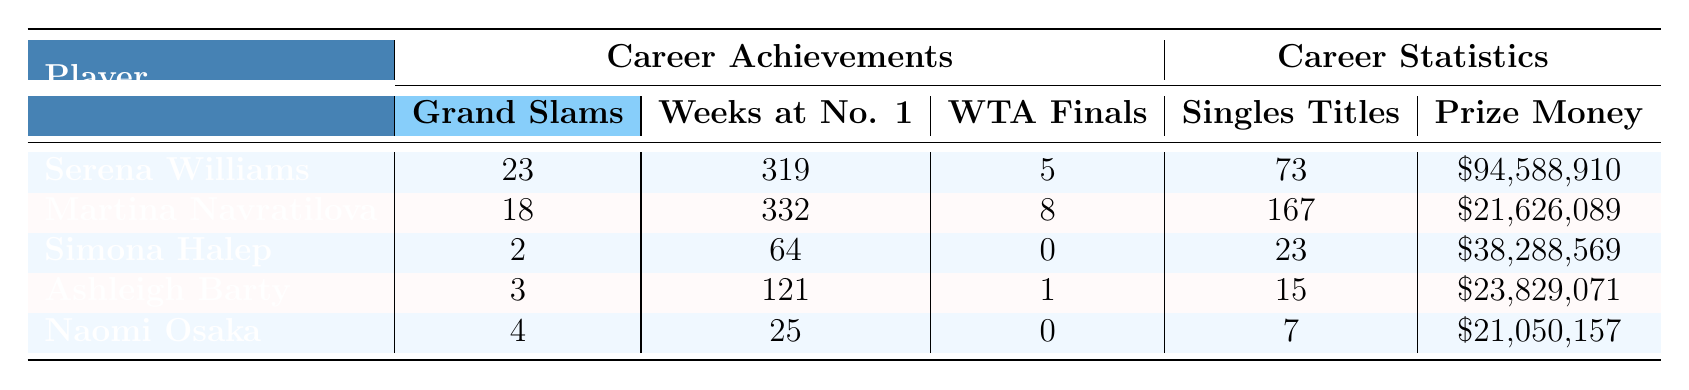What is the total number of Grand Slam titles won by Serena Williams and Martina Navratilova combined? Serena Williams has won 23 Grand Slam singles titles, and Martina Navratilova has won 18. Adding these together: 23 + 18 = 41.
Answer: 41 Which player has the highest number of career singles titles? The table shows that Martina Navratilova has the highest number of career singles titles with a total of 167.
Answer: 167 Did Ashleigh Barty win more doubles titles than singles titles? Ashleigh Barty has won 12 doubles titles and 15 singles titles. Since 12 is less than 15, she did not win more doubles titles than singles titles.
Answer: No How many weeks did Simona Halep spend at World No. 1 compared to Naomi Osaka? Simona Halep spent 64 weeks at World No. 1, while Naomi Osaka spent 25 weeks. The difference is 64 - 25 = 39 weeks.
Answer: 39 Which player has the most career prize money? According to the table, Serena Williams has the highest career prize money, totaling $94,588,910.
Answer: $94,588,910 What is the average number of Grand Slam titles won by the top female players listed in the table? The players listed have Grand Slam titles as follows: 23, 18, 2, 3, and 4. Adding them gives: 23 + 18 + 2 + 3 + 4 = 50. There are 5 players, so the average is 50/5 = 10.
Answer: 10 Is it true that all listed players have won at least one WTA Tour Championship? The table shows that Simona Halep has not won any WTA Tour Championships (0), so it is not true that all players have won at least one.
Answer: No What is the difference in the number of weeks at World No. 1 between Serena Williams and Ashleigh Barty? Serena Williams spent 319 weeks at World No. 1 and Ashleigh Barty spent 121 weeks. The difference is 319 - 121 = 198 weeks.
Answer: 198 How many total Olympic medals do Serena Williams and Simona Halep have combined? Serena Williams has won 4 Olympic medals, and Simona Halep has won 0 Olympic medals. Combining these gives: 4 + 0 = 4.
Answer: 4 Which player has the lowest career prize money, and what is that amount? The table reveals that Naomi Osaka has the lowest career prize money, which is $21,050,157.
Answer: $21,050,157 